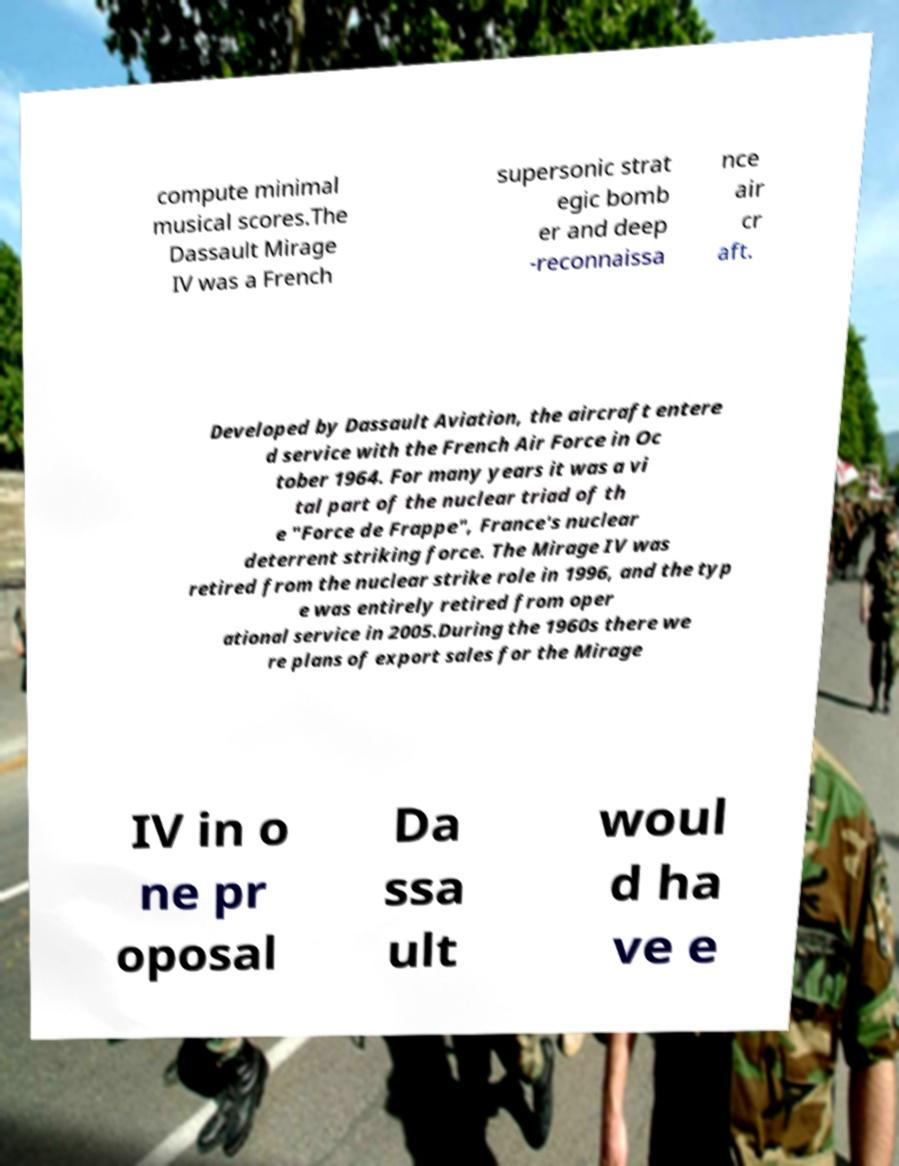Can you read and provide the text displayed in the image?This photo seems to have some interesting text. Can you extract and type it out for me? compute minimal musical scores.The Dassault Mirage IV was a French supersonic strat egic bomb er and deep -reconnaissa nce air cr aft. Developed by Dassault Aviation, the aircraft entere d service with the French Air Force in Oc tober 1964. For many years it was a vi tal part of the nuclear triad of th e "Force de Frappe", France's nuclear deterrent striking force. The Mirage IV was retired from the nuclear strike role in 1996, and the typ e was entirely retired from oper ational service in 2005.During the 1960s there we re plans of export sales for the Mirage IV in o ne pr oposal Da ssa ult woul d ha ve e 